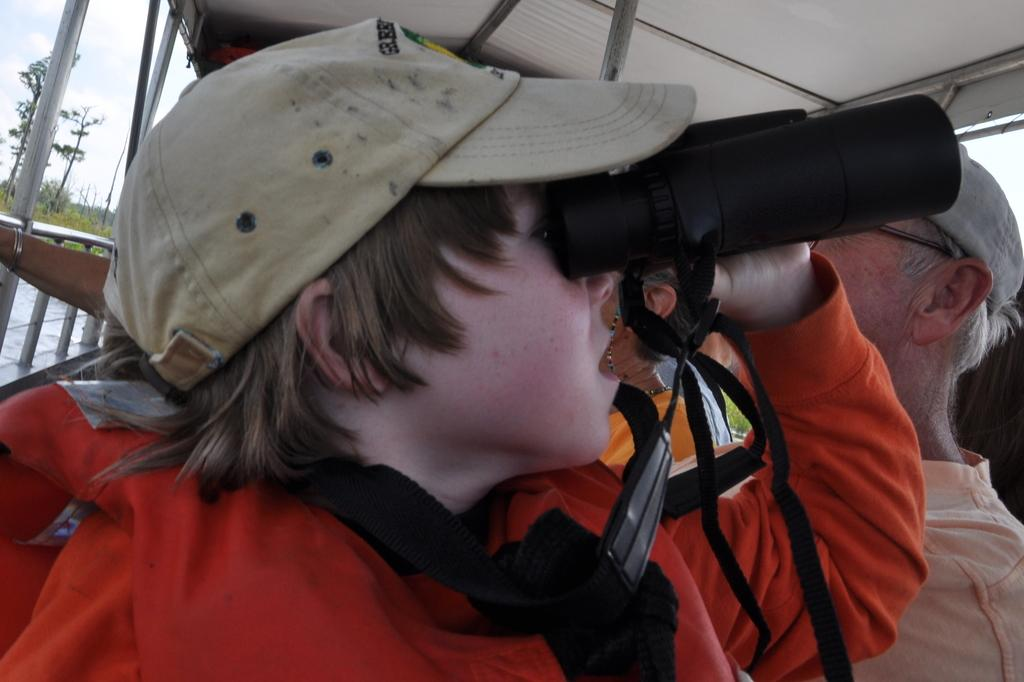What is the main subject of the image? There is a child in the image. What is the child holding in the image? The child is holding binoculars. What type of clothing is the child wearing? The child is wearing a cap. What can be seen in the background of the image? There are trees and other people in the background of the image. What is visible at the top of the image? There is a roof visible at the top of the image. What type of trousers is the child wearing in the image? The provided facts do not mention the type of trousers the child is wearing, so we cannot answer this question definitively. How many cows are visible in the image? There are no cows present in the image. 